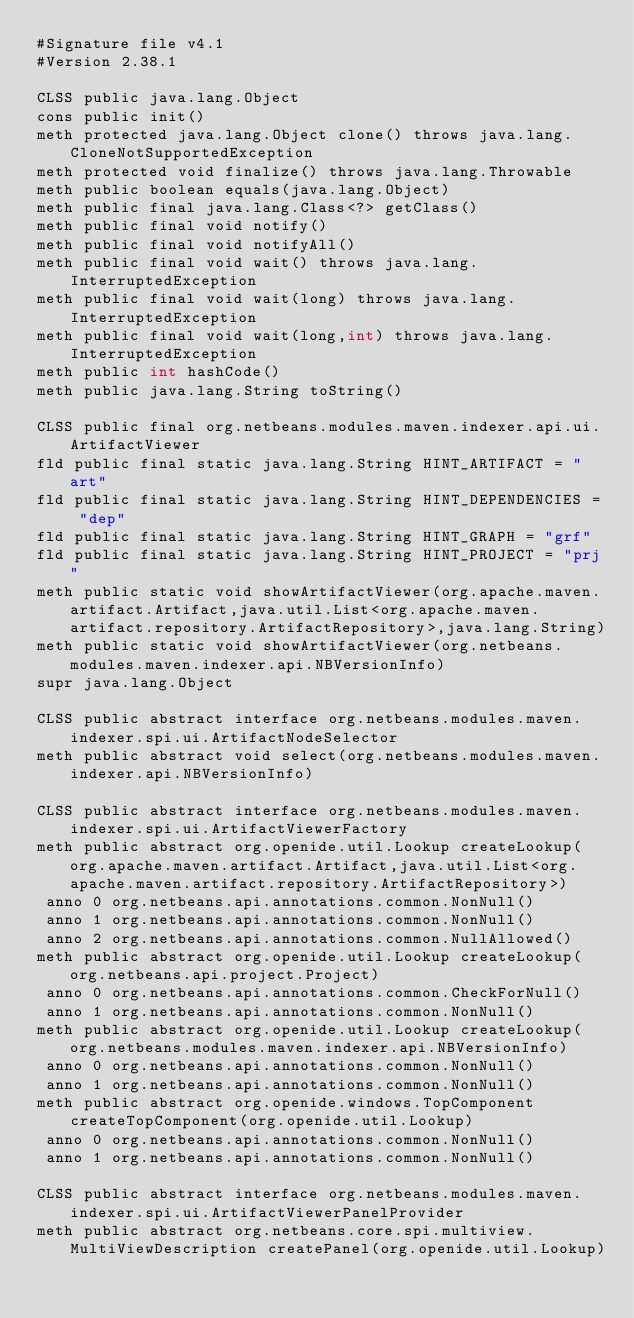<code> <loc_0><loc_0><loc_500><loc_500><_SML_>#Signature file v4.1
#Version 2.38.1

CLSS public java.lang.Object
cons public init()
meth protected java.lang.Object clone() throws java.lang.CloneNotSupportedException
meth protected void finalize() throws java.lang.Throwable
meth public boolean equals(java.lang.Object)
meth public final java.lang.Class<?> getClass()
meth public final void notify()
meth public final void notifyAll()
meth public final void wait() throws java.lang.InterruptedException
meth public final void wait(long) throws java.lang.InterruptedException
meth public final void wait(long,int) throws java.lang.InterruptedException
meth public int hashCode()
meth public java.lang.String toString()

CLSS public final org.netbeans.modules.maven.indexer.api.ui.ArtifactViewer
fld public final static java.lang.String HINT_ARTIFACT = "art"
fld public final static java.lang.String HINT_DEPENDENCIES = "dep"
fld public final static java.lang.String HINT_GRAPH = "grf"
fld public final static java.lang.String HINT_PROJECT = "prj"
meth public static void showArtifactViewer(org.apache.maven.artifact.Artifact,java.util.List<org.apache.maven.artifact.repository.ArtifactRepository>,java.lang.String)
meth public static void showArtifactViewer(org.netbeans.modules.maven.indexer.api.NBVersionInfo)
supr java.lang.Object

CLSS public abstract interface org.netbeans.modules.maven.indexer.spi.ui.ArtifactNodeSelector
meth public abstract void select(org.netbeans.modules.maven.indexer.api.NBVersionInfo)

CLSS public abstract interface org.netbeans.modules.maven.indexer.spi.ui.ArtifactViewerFactory
meth public abstract org.openide.util.Lookup createLookup(org.apache.maven.artifact.Artifact,java.util.List<org.apache.maven.artifact.repository.ArtifactRepository>)
 anno 0 org.netbeans.api.annotations.common.NonNull()
 anno 1 org.netbeans.api.annotations.common.NonNull()
 anno 2 org.netbeans.api.annotations.common.NullAllowed()
meth public abstract org.openide.util.Lookup createLookup(org.netbeans.api.project.Project)
 anno 0 org.netbeans.api.annotations.common.CheckForNull()
 anno 1 org.netbeans.api.annotations.common.NonNull()
meth public abstract org.openide.util.Lookup createLookup(org.netbeans.modules.maven.indexer.api.NBVersionInfo)
 anno 0 org.netbeans.api.annotations.common.NonNull()
 anno 1 org.netbeans.api.annotations.common.NonNull()
meth public abstract org.openide.windows.TopComponent createTopComponent(org.openide.util.Lookup)
 anno 0 org.netbeans.api.annotations.common.NonNull()
 anno 1 org.netbeans.api.annotations.common.NonNull()

CLSS public abstract interface org.netbeans.modules.maven.indexer.spi.ui.ArtifactViewerPanelProvider
meth public abstract org.netbeans.core.spi.multiview.MultiViewDescription createPanel(org.openide.util.Lookup)

</code> 